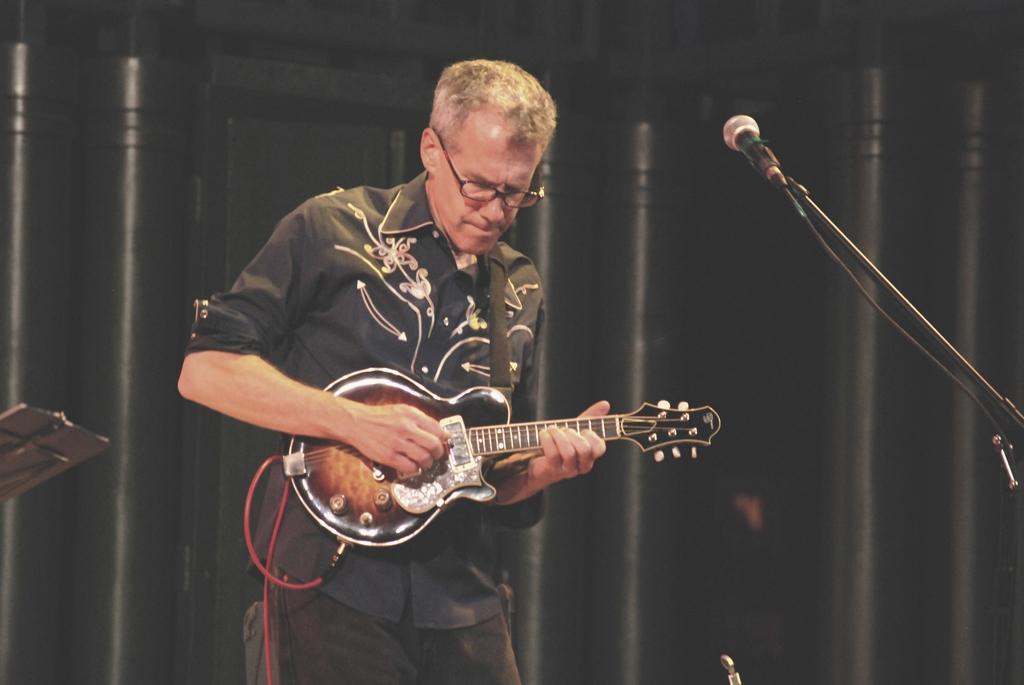What is the man in the image doing? The man is playing a guitar. What is the man standing in front of? The man is standing in front of a microphone. What is the man wearing on his upper body? The man is wearing a black shirt. What accessory is the man wearing on his face? The man is wearing spectacles. What type of cake is being served in the scene? There is no cake present in the image, and the term "scene" is not applicable as it implies a broader context or setting, which is not mentioned in the facts. 